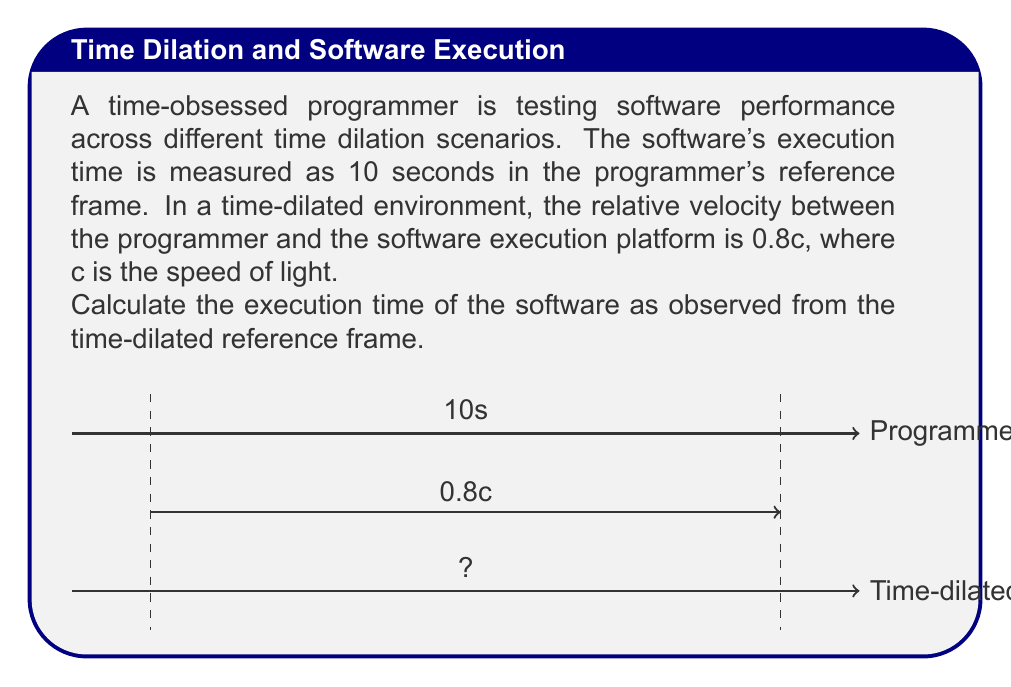Can you solve this math problem? To solve this problem, we need to use the time dilation formula from special relativity:

$$t' = \frac{t}{\sqrt{1 - \frac{v^2}{c^2}}}$$

Where:
- $t'$ is the dilated time (what we're solving for)
- $t$ is the proper time (10 seconds in the programmer's frame)
- $v$ is the relative velocity (0.8c)
- $c$ is the speed of light

Steps:
1) First, let's substitute the known values into the formula:

   $$t' = \frac{10}{\sqrt{1 - \frac{(0.8c)^2}{c^2}}}$$

2) Simplify inside the square root:

   $$t' = \frac{10}{\sqrt{1 - 0.64}}$$

3) Calculate the value under the square root:

   $$t' = \frac{10}{\sqrt{0.36}}$$

4) Simplify the square root:

   $$t' = \frac{10}{0.6}$$

5) Perform the division:

   $$t' = 16.67$$

Therefore, the execution time observed in the time-dilated frame is approximately 16.67 seconds.
Answer: 16.67 seconds 